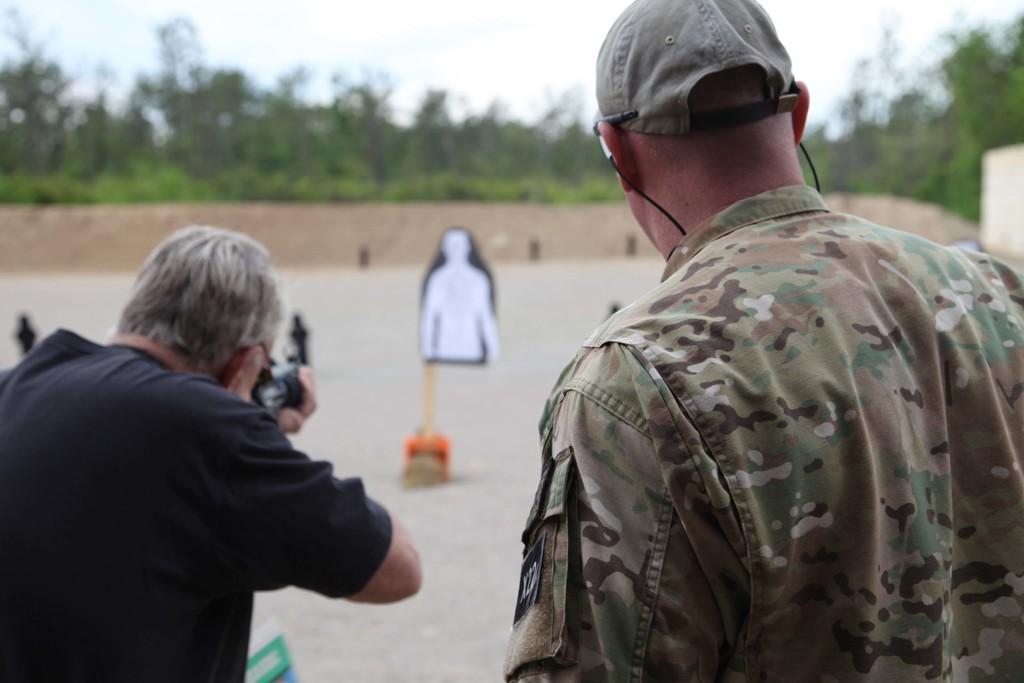Can you describe this image briefly? In this image we can see a man on the right side and he is a soldier. Here we can see a cap on his head. Here we can see another man on the left side and he is holding a weapon in his hand. Here we can see the target board stand. In the background, we can see the trees. 